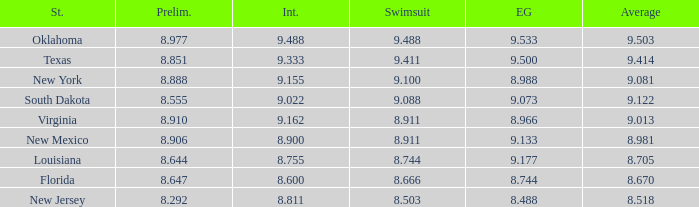What is the total number of average where evening gown is 8.988 1.0. 